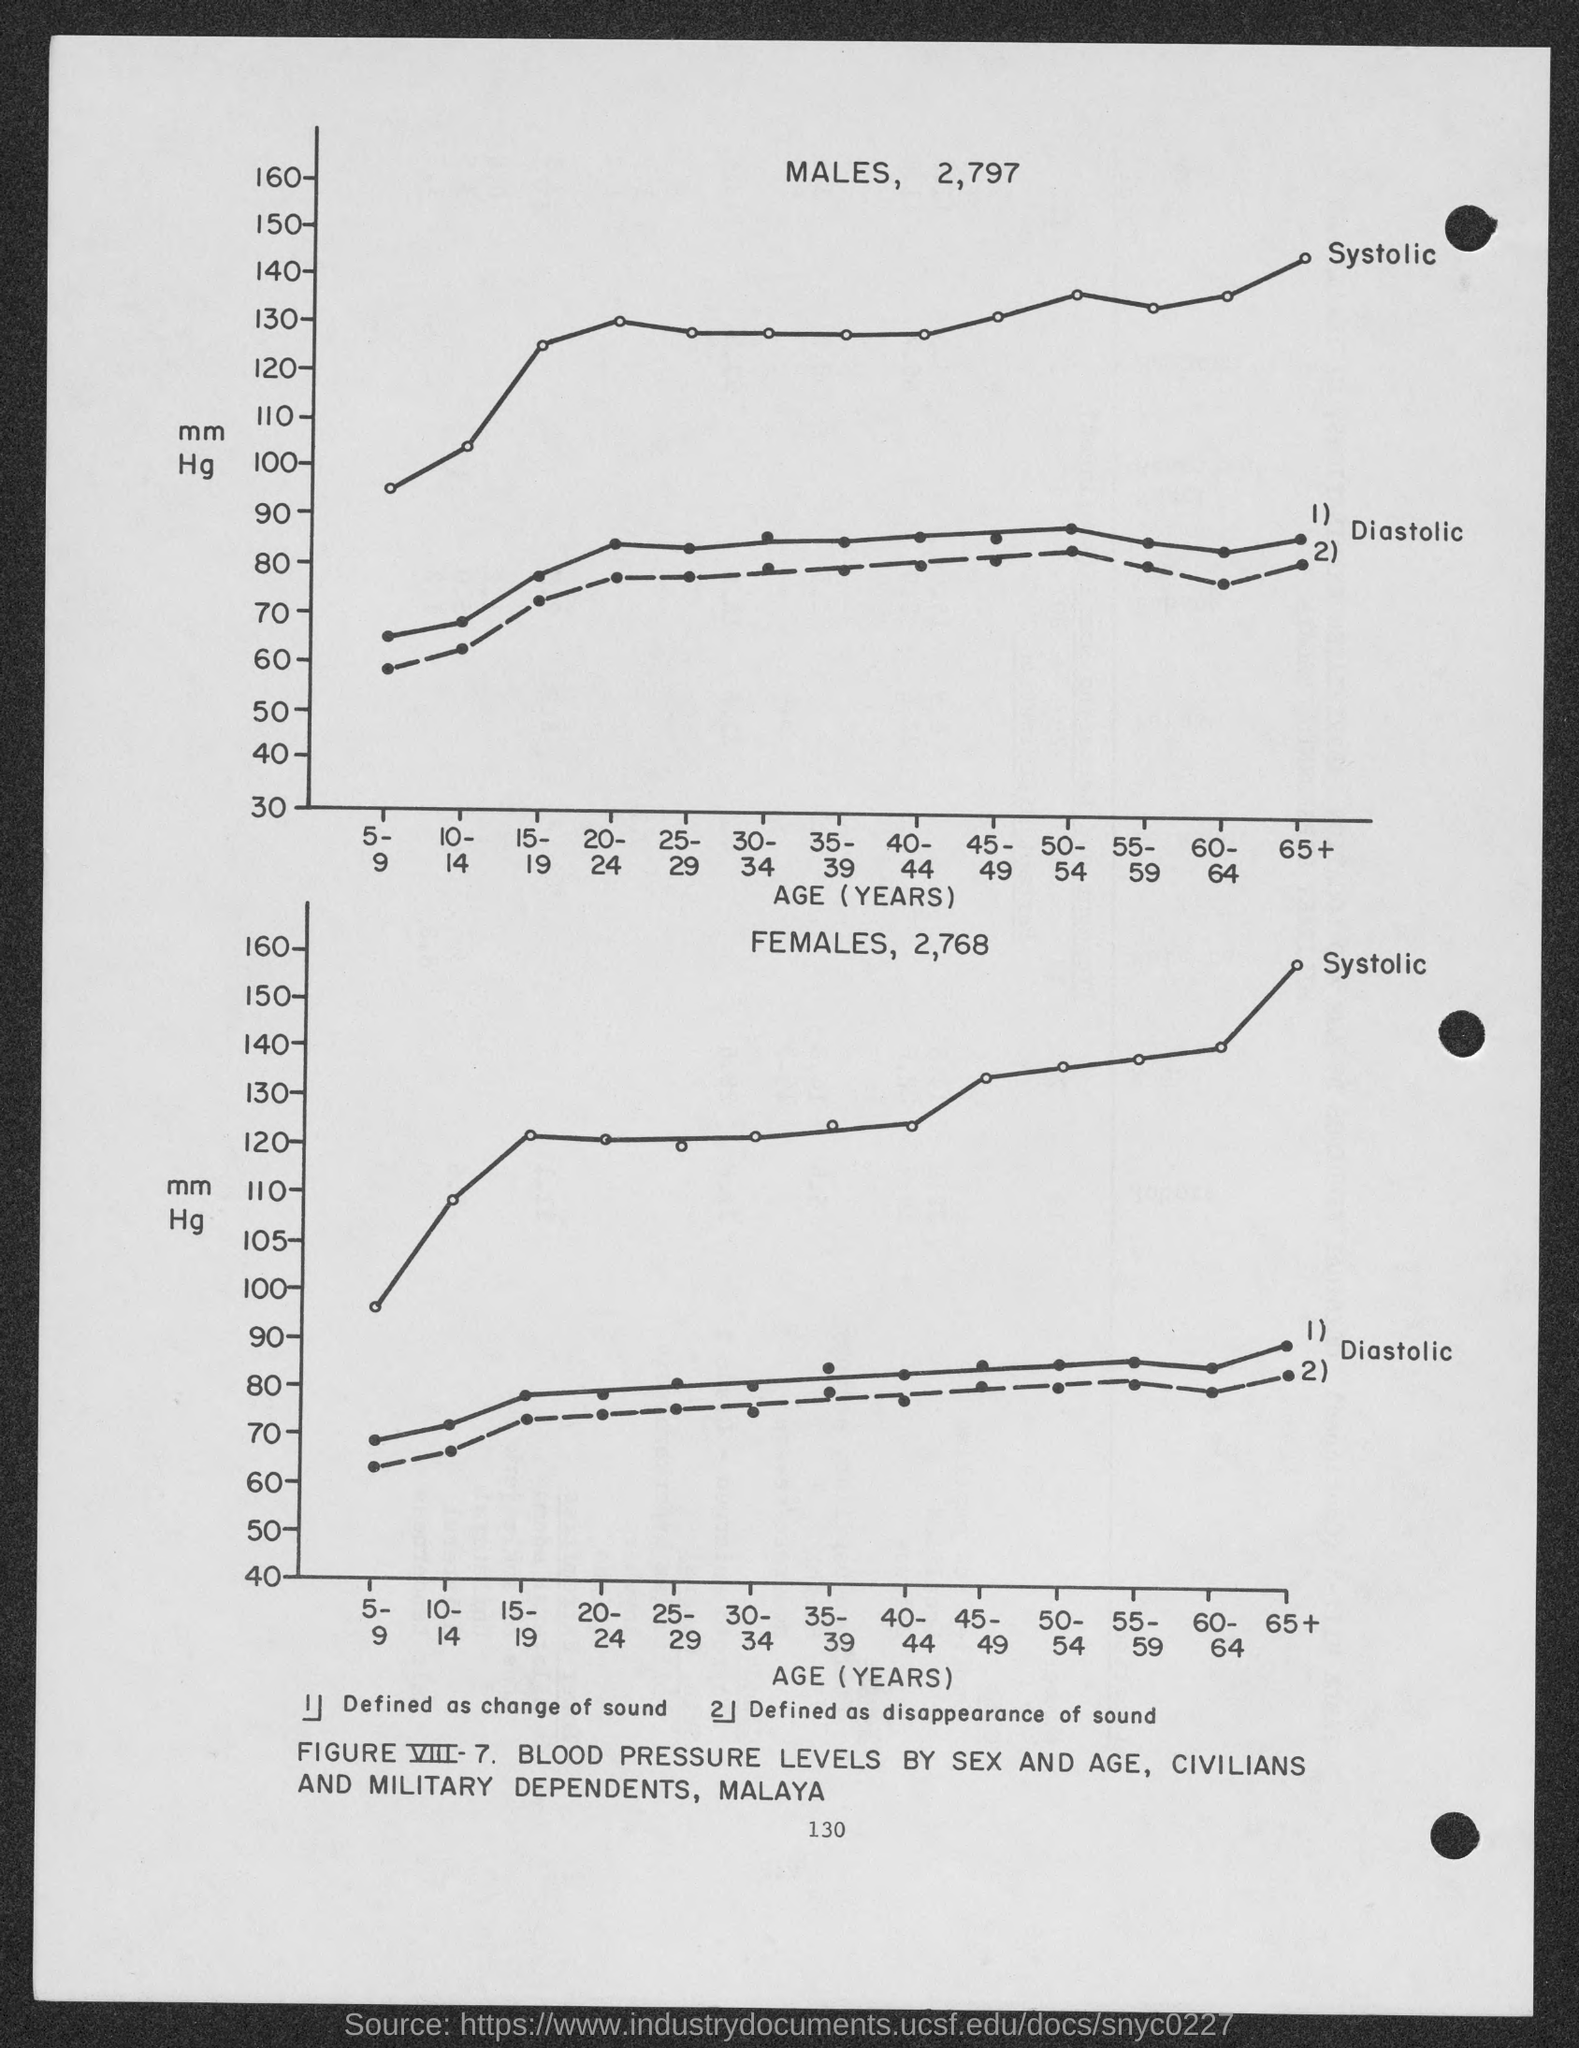What is the number at bottom of the page ?
Your response must be concise. 130. 